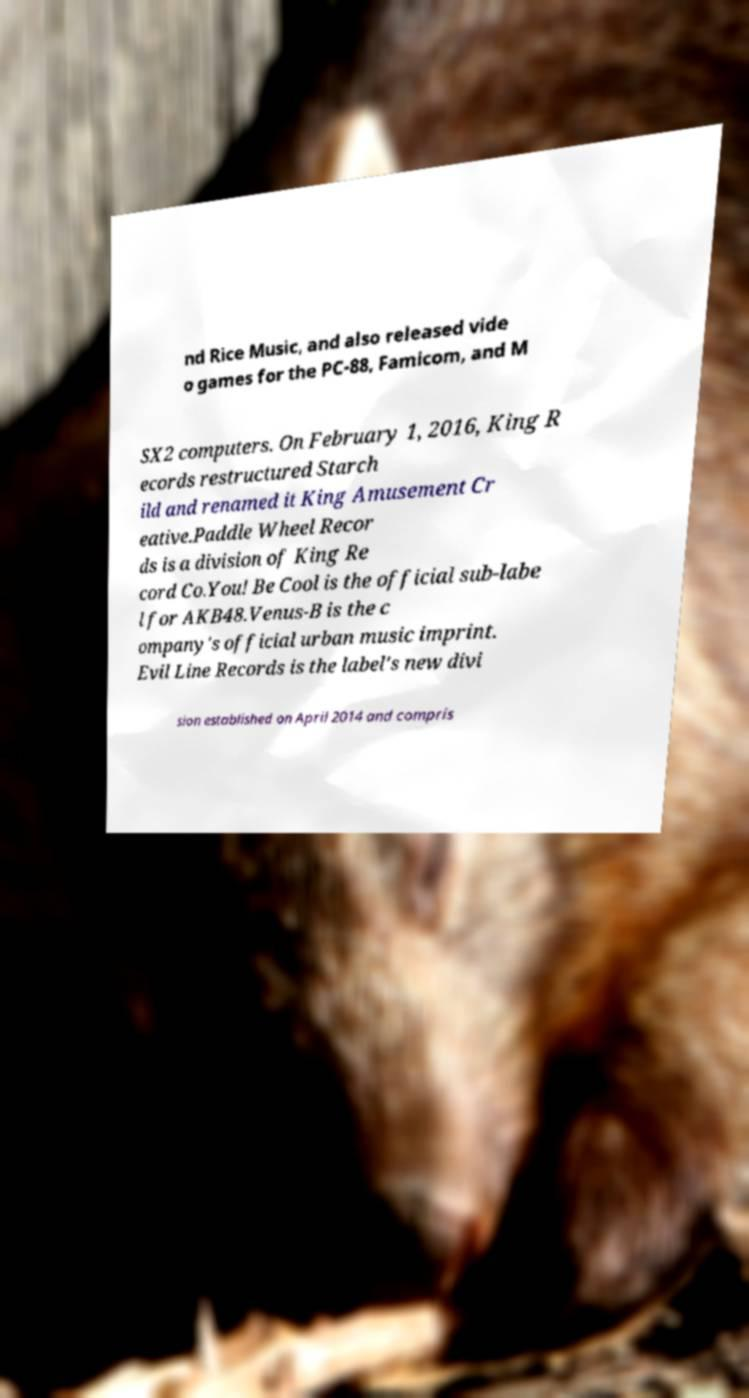Can you read and provide the text displayed in the image?This photo seems to have some interesting text. Can you extract and type it out for me? nd Rice Music, and also released vide o games for the PC-88, Famicom, and M SX2 computers. On February 1, 2016, King R ecords restructured Starch ild and renamed it King Amusement Cr eative.Paddle Wheel Recor ds is a division of King Re cord Co.You! Be Cool is the official sub-labe l for AKB48.Venus-B is the c ompany's official urban music imprint. Evil Line Records is the label's new divi sion established on April 2014 and compris 